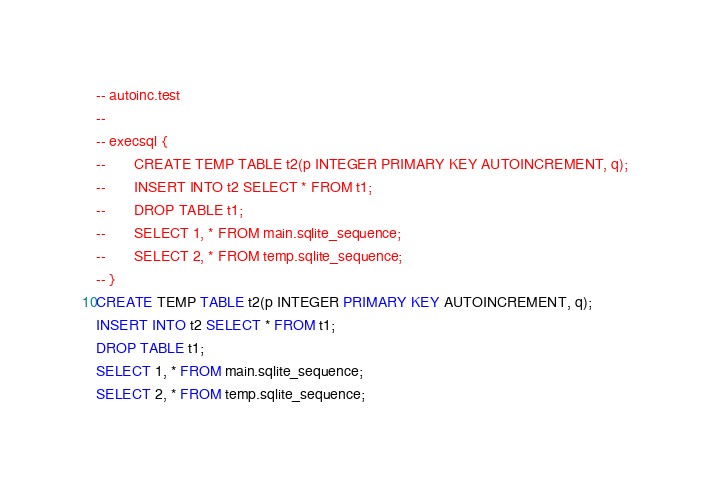<code> <loc_0><loc_0><loc_500><loc_500><_SQL_>-- autoinc.test
-- 
-- execsql {
--       CREATE TEMP TABLE t2(p INTEGER PRIMARY KEY AUTOINCREMENT, q);
--       INSERT INTO t2 SELECT * FROM t1;
--       DROP TABLE t1;
--       SELECT 1, * FROM main.sqlite_sequence;
--       SELECT 2, * FROM temp.sqlite_sequence;
-- }
CREATE TEMP TABLE t2(p INTEGER PRIMARY KEY AUTOINCREMENT, q);
INSERT INTO t2 SELECT * FROM t1;
DROP TABLE t1;
SELECT 1, * FROM main.sqlite_sequence;
SELECT 2, * FROM temp.sqlite_sequence;</code> 